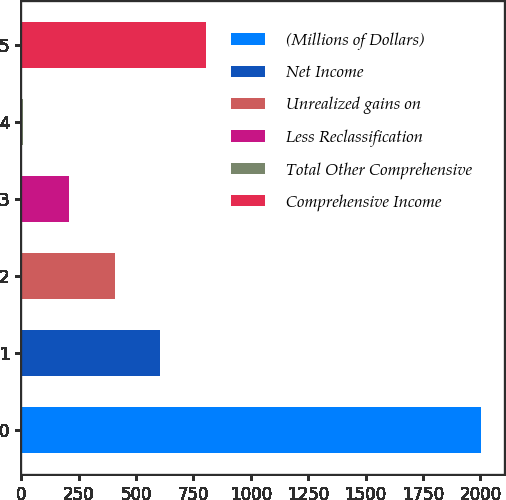<chart> <loc_0><loc_0><loc_500><loc_500><bar_chart><fcel>(Millions of Dollars)<fcel>Net Income<fcel>Unrealized gains on<fcel>Less Reclassification<fcel>Total Other Comprehensive<fcel>Comprehensive Income<nl><fcel>2004<fcel>606.1<fcel>406.4<fcel>206.7<fcel>7<fcel>805.8<nl></chart> 